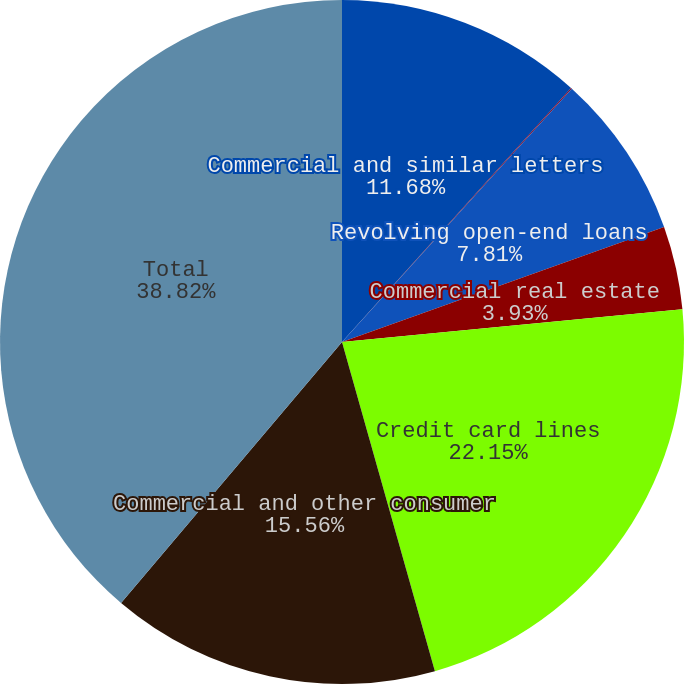Convert chart to OTSL. <chart><loc_0><loc_0><loc_500><loc_500><pie_chart><fcel>Commercial and similar letters<fcel>One- to four-family<fcel>Revolving open-end loans<fcel>Commercial real estate<fcel>Credit card lines<fcel>Commercial and other consumer<fcel>Total<nl><fcel>11.68%<fcel>0.05%<fcel>7.81%<fcel>3.93%<fcel>22.15%<fcel>15.56%<fcel>38.82%<nl></chart> 